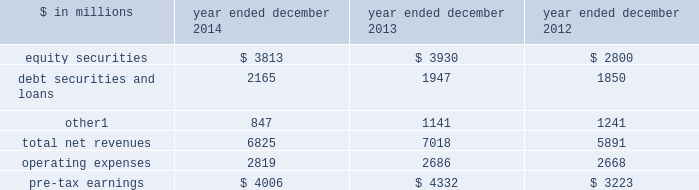Management 2019s discussion and analysis investing & lending investing & lending includes our investing activities and the origination of loans to provide financing to clients .
These investments and loans are typically longer-term in nature .
We make investments , some of which are consolidated , directly and indirectly through funds that we manage , in debt securities and loans , public and private equity securities , and real estate entities .
The table below presents the operating results of our investing & lending segment. .
Includes net revenues of $ 325 million for 2014 , $ 329 million for 2013 and $ 362 million for 2012 related to metro international trade services llc .
We completed the sale of this consolidated investment in december 2014 .
2014 versus 2013 .
Net revenues in investing & lending were $ 6.83 billion for 2014 , 3% ( 3 % ) lower than 2013 .
Net gains from investments in equity securities were slightly lower due to a significant decrease in net gains from investments in public equities , as movements in global equity prices during 2014 were less favorable compared with 2013 , partially offset by an increase in net gains from investments in private equities , primarily driven by company-specific events .
Net revenues from debt securities and loans were higher than 2013 , reflecting a significant increase in net interest income , primarily driven by increased lending , and a slight increase in net gains , primarily due to sales of certain investments during 2014 .
Other net revenues , related to our consolidated investments , were significantly lower compared with 2013 , reflecting a decrease in operating revenues from commodities-related consolidated investments .
During 2014 , net revenues in investing & lending generally reflected favorable company-specific events , including initial public offerings and financings , and strong corporate performance , as well as net gains from sales of certain investments .
However , concerns about the outlook for the global economy and uncertainty over the impact of financial regulatory reform continue to be meaningful considerations for the global marketplace .
If equity markets decline or credit spreads widen , net revenues in investing & lending would likely be negatively impacted .
Operating expenses were $ 2.82 billion for 2014 , 5% ( 5 % ) higher than 2013 , reflecting higher compensation and benefits expenses , partially offset by lower expenses related to consolidated investments .
Pre-tax earnings were $ 4.01 billion in 2014 , 8% ( 8 % ) lower than 2013 .
2013 versus 2012 .
Net revenues in investing & lending were $ 7.02 billion for 2013 , 19% ( 19 % ) higher than 2012 , reflecting a significant increase in net gains from investments in equity securities , driven by company-specific events and stronger corporate performance , as well as significantly higher global equity prices .
In addition , net gains and net interest income from debt securities and loans were slightly higher , while other net revenues , related to our consolidated investments , were lower compared with 2012 .
During 2013 , net revenues in investing & lending generally reflected favorable company-specific events and strong corporate performance , as well as the impact of significantly higher global equity prices and tighter corporate credit spreads .
Operating expenses were $ 2.69 billion for 2013 , essentially unchanged compared with 2012 .
Operating expenses during 2013 included lower impairment charges and lower operating expenses related to consolidated investments , partially offset by increased compensation and benefits expenses due to higher net revenues compared with 2012 .
Pre-tax earnings were $ 4.33 billion in 2013 , 34% ( 34 % ) higher than 2012 .
Goldman sachs 2014 annual report 45 .
In 2013 what percentage of total net revenues for the investing & lending segment were due to debt securities and loans? 
Computations: (1947 / 7018)
Answer: 0.27743. 